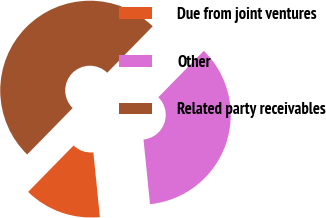Convert chart. <chart><loc_0><loc_0><loc_500><loc_500><pie_chart><fcel>Due from joint ventures<fcel>Other<fcel>Related party receivables<nl><fcel>13.93%<fcel>36.07%<fcel>50.0%<nl></chart> 